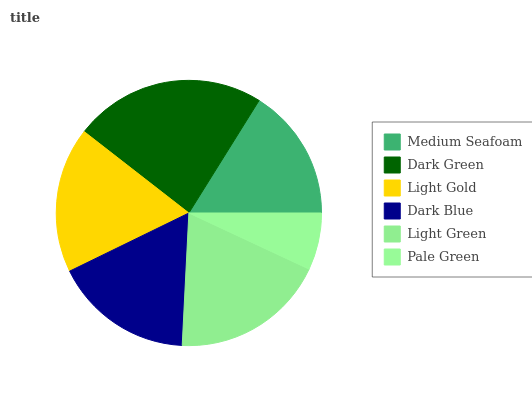Is Pale Green the minimum?
Answer yes or no. Yes. Is Dark Green the maximum?
Answer yes or no. Yes. Is Light Gold the minimum?
Answer yes or no. No. Is Light Gold the maximum?
Answer yes or no. No. Is Dark Green greater than Light Gold?
Answer yes or no. Yes. Is Light Gold less than Dark Green?
Answer yes or no. Yes. Is Light Gold greater than Dark Green?
Answer yes or no. No. Is Dark Green less than Light Gold?
Answer yes or no. No. Is Light Gold the high median?
Answer yes or no. Yes. Is Dark Blue the low median?
Answer yes or no. Yes. Is Light Green the high median?
Answer yes or no. No. Is Medium Seafoam the low median?
Answer yes or no. No. 